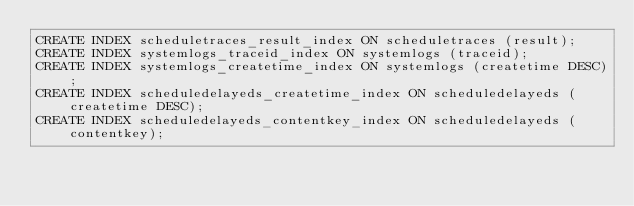Convert code to text. <code><loc_0><loc_0><loc_500><loc_500><_SQL_>CREATE INDEX scheduletraces_result_index ON scheduletraces (result);
CREATE INDEX systemlogs_traceid_index ON systemlogs (traceid);
CREATE INDEX systemlogs_createtime_index ON systemlogs (createtime DESC);
CREATE INDEX scheduledelayeds_createtime_index ON scheduledelayeds (createtime DESC);
CREATE INDEX scheduledelayeds_contentkey_index ON scheduledelayeds (contentkey);</code> 